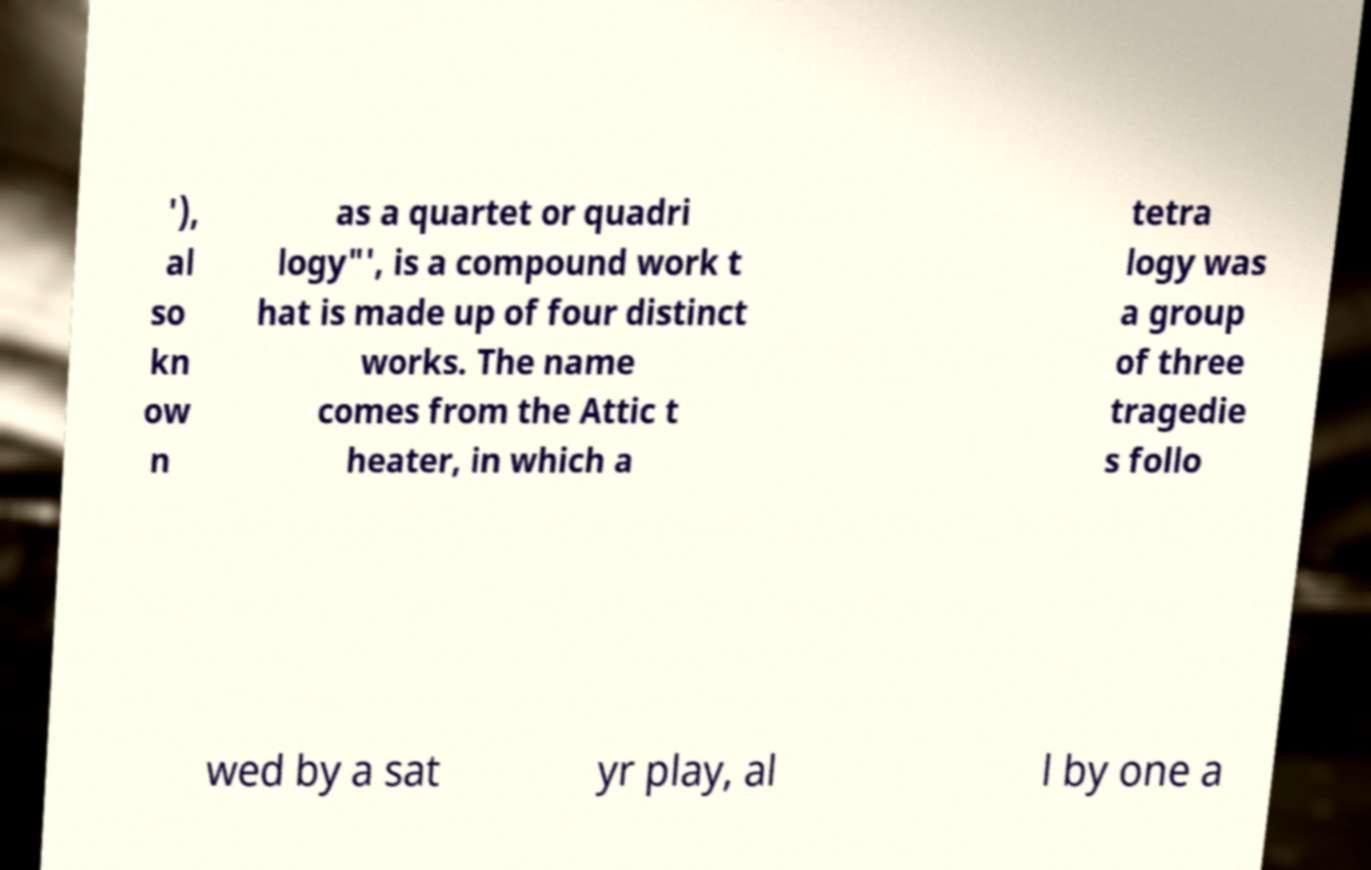For documentation purposes, I need the text within this image transcribed. Could you provide that? '), al so kn ow n as a quartet or quadri logy"', is a compound work t hat is made up of four distinct works. The name comes from the Attic t heater, in which a tetra logy was a group of three tragedie s follo wed by a sat yr play, al l by one a 